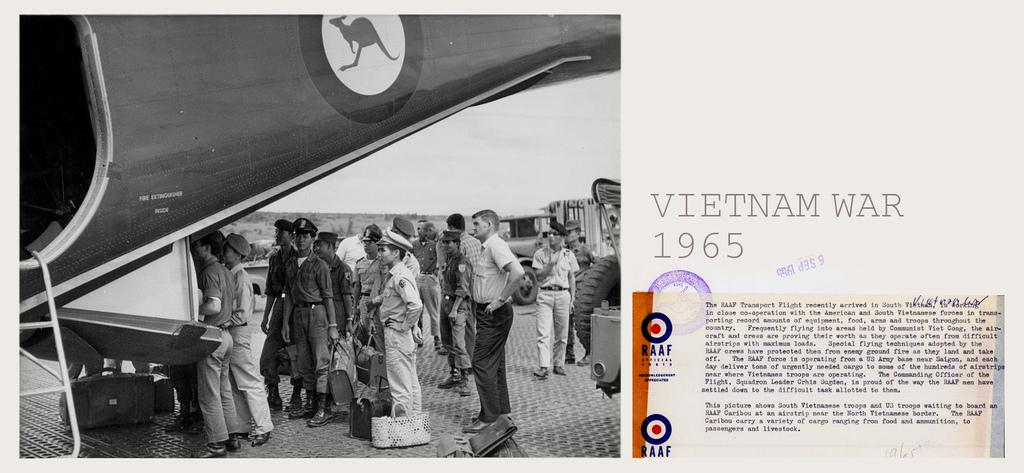What type of image is being described? The image is a poster. What are the people in the poster doing? The people in the poster are standing and holding bags. What can be seen behind the people in the poster? There are vehicles visible behind the people. Where is the plane located in the poster? The plane is on the left side of the poster. How much money is being exchanged between the people in the poster? There is no indication of money being exchanged in the poster; the people are simply standing and holding bags. Who is the friend of the person standing on the right side of the poster? There is no friend mentioned or depicted in the poster; it only shows people standing and holding bags. 